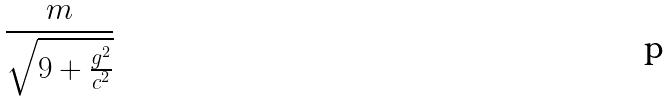Convert formula to latex. <formula><loc_0><loc_0><loc_500><loc_500>\frac { m } { \sqrt { 9 + \frac { g ^ { 2 } } { c ^ { 2 } } } }</formula> 